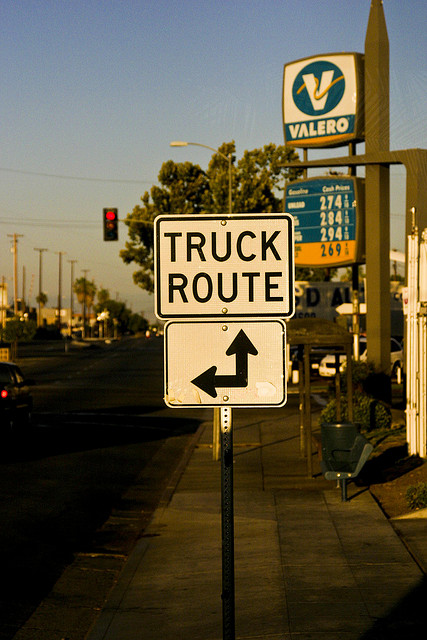Read all the text in this image. TRUCK ROUTE VALERO 274 269 D 294 284 